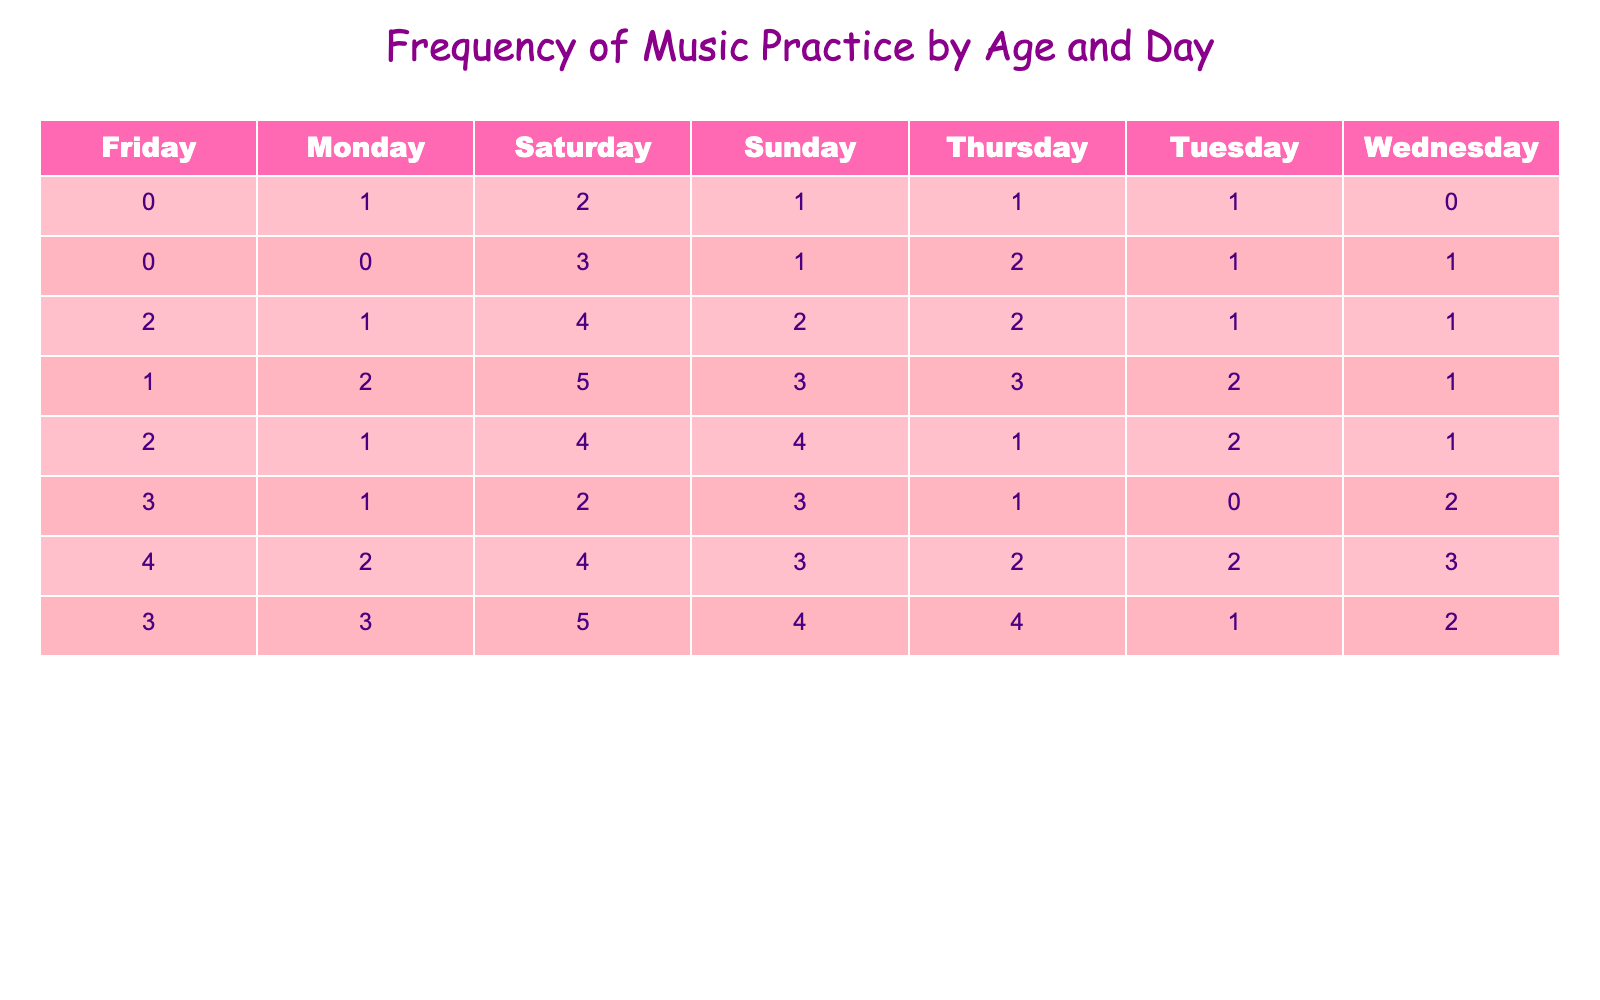What's the frequency of music practice for 8-year-olds on Saturdays? From the table, we look under the age of 8 and find the column for Saturday, which shows the frequency value of 5.
Answer: 5 Which age group practiced music the most on Fridays? By examining the Friday column, we find the maximum value is 4 for the 11-year-olds.
Answer: 11 years old Is there any age group that practiced music 0 times on Tuesdays? Looking at the Tuesday column, the 5-year-olds practiced 1 time, while others show at least 1, indicating no age group practiced 0 times on Tuesdays.
Answer: No What is the total frequency of music practice for 6-year-olds across all days? We sum the values for the 6-year-olds: 0 + 1 + 1 + 2 + 0 + 3 + 1 = 8. Therefore, the total frequency is 8.
Answer: 8 Which day had the highest overall frequency of practice across all ages? Adding the frequencies for each day: Monday (1+0+1+2+1+1+2+3=11), Tuesday (1+1+1+2+2+0+2+1=10), Wednesday (0+1+1+1+1+2+3+2=11), Thursday (1+2+3+1+1+1+2+4=16), Friday (0+0+2+1+2+3+4+3=15), Saturday (2+3+4+5+4+2+4+5=25), Sunday (1+1+2+3+4+3+4+4=20). So, Saturday had the highest frequency with 25.
Answer: Saturday What is the average frequency of music practice for the 9-year-olds? Sum the values for the 9-year-olds: 1 + 2 + 1 + 1 + 2 + 4 + 4 = 15. There are 7 days, so the average is 15/7, which is approximately 2.14.
Answer: 2.14 Did any age group practice more often on Sundays than on Fridays? Comparing the Sunday and Friday frequencies for each age: 5 (1 vs 0), 6 (1 vs 0), 7 (2 vs 2), 8 (3 vs 1), 9 (4 vs 2), 10 (3 vs 3), 11 (3 vs 4), 12 (4 vs 3). Ages 8, 9, and 12 practiced more on Sundays than Fridays.
Answer: Yes What is the combined frequency of music practice for ages 10 and 11 on Thursdays? The frequency for age 10 on Thursday is 1, and for age 11 it is 2. Adding these together gives us 1 + 2 = 3.
Answer: 3 Which age group has the highest total frequency of practice for the entire week? Calculate the total frequency for each age: 5 (1+1+0+1+0+2+1=6), 6 (0+1+1+2+0+3+1=8), 7 (1+1+1+2+2+4+2=13), 8 (2+2+1+3+1+5+3=17), 9 (1+2+1+1+2+4+4=12), 10 (1+0+2+1+3+2+3=12), 11 (2+2+3+2+4+4+3=22), 12 (3+1+2+4+3+5+4=24). The highest total is for the 12-year-olds with 24.
Answer: 12 years old 